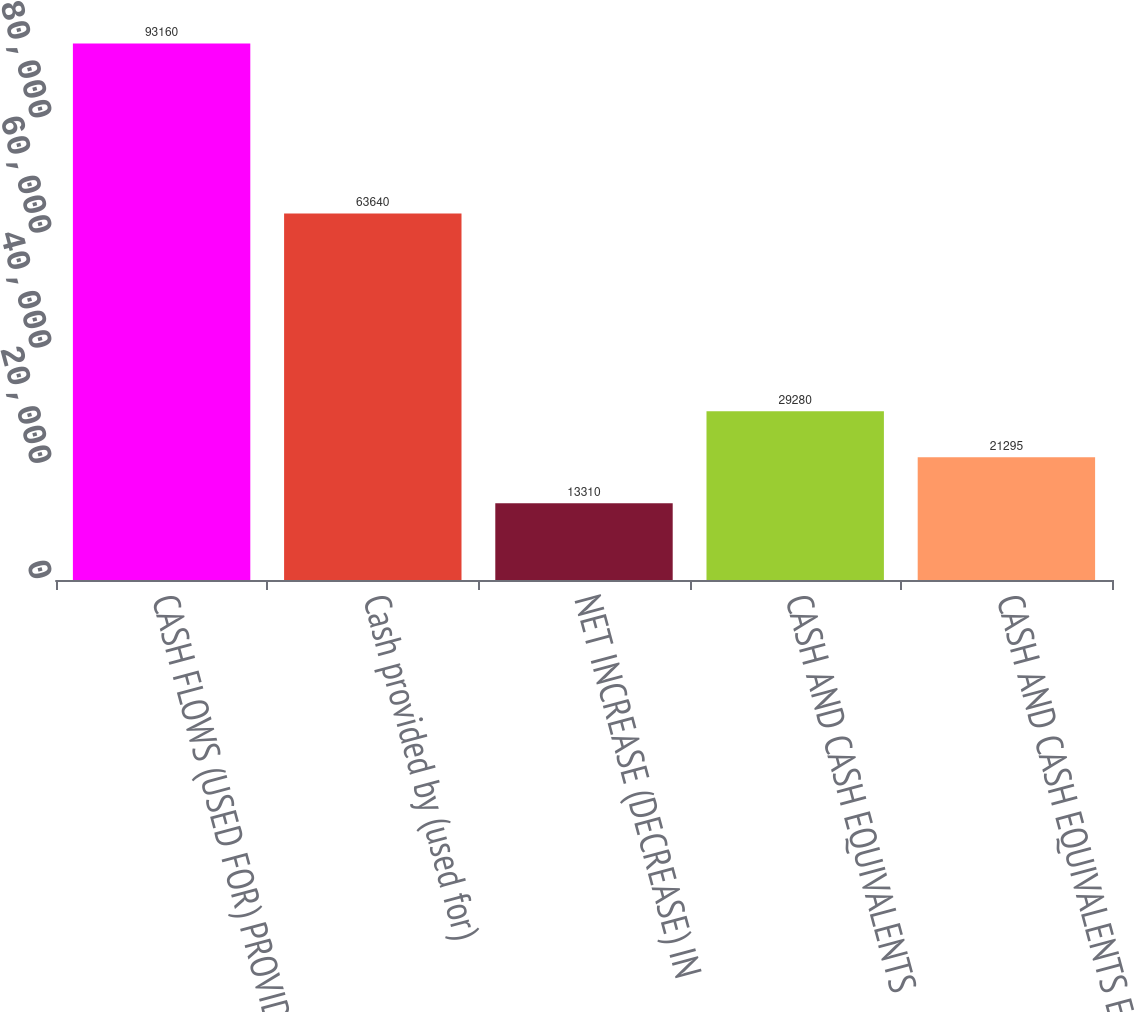Convert chart. <chart><loc_0><loc_0><loc_500><loc_500><bar_chart><fcel>CASH FLOWS (USED FOR) PROVIDED<fcel>Cash provided by (used for)<fcel>NET INCREASE (DECREASE) IN<fcel>CASH AND CASH EQUIVALENTS<fcel>CASH AND CASH EQUIVALENTS END<nl><fcel>93160<fcel>63640<fcel>13310<fcel>29280<fcel>21295<nl></chart> 